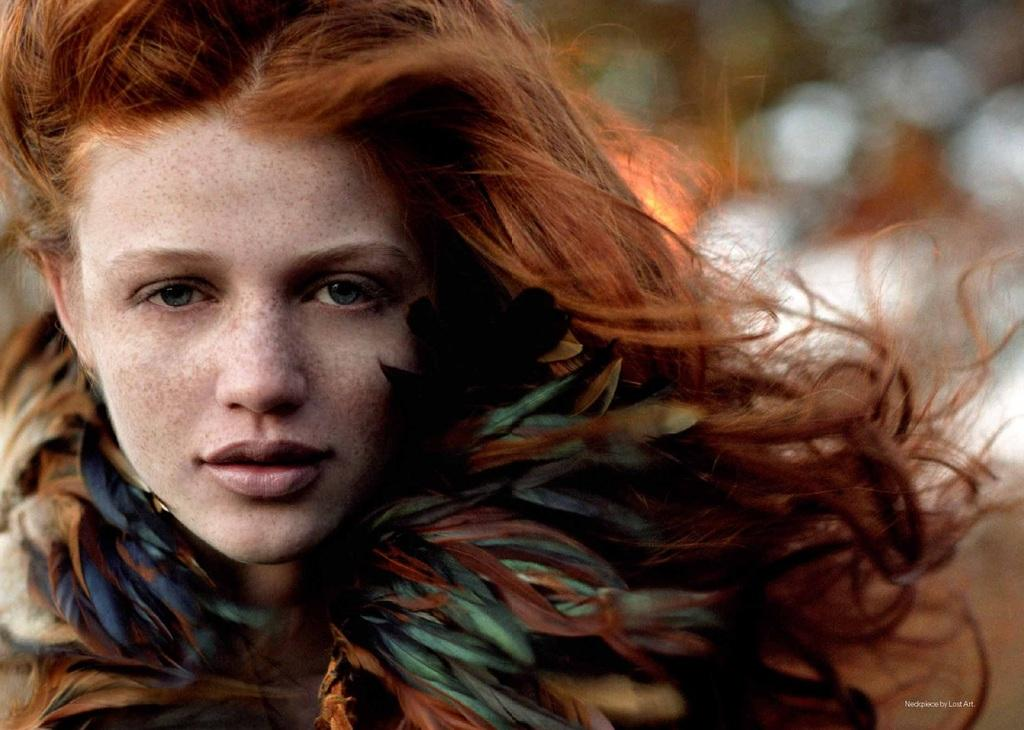Who is the main subject in the foreground of the image? There is a lady in the foreground of the image. What can be observed about the background of the image? The background of the image is blurred. What type of cake is being washed in the image? There is no cake present in the image, and no washing is depicted. 